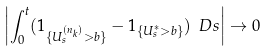<formula> <loc_0><loc_0><loc_500><loc_500>\left | \int _ { 0 } ^ { t } ( 1 _ { \{ U ^ { ( n _ { k } ) } _ { s } > b \} } - 1 _ { \{ U ^ { * } _ { s } > b \} } ) \ D s \right | \rightarrow 0</formula> 